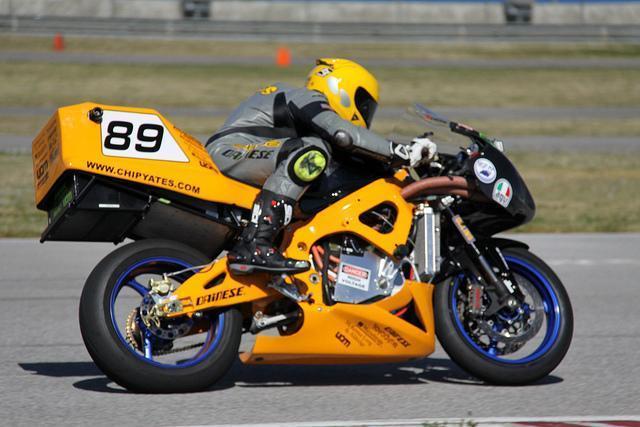How many motorcycles can be seen?
Give a very brief answer. 1. How many dogs are on he bench in this image?
Give a very brief answer. 0. 